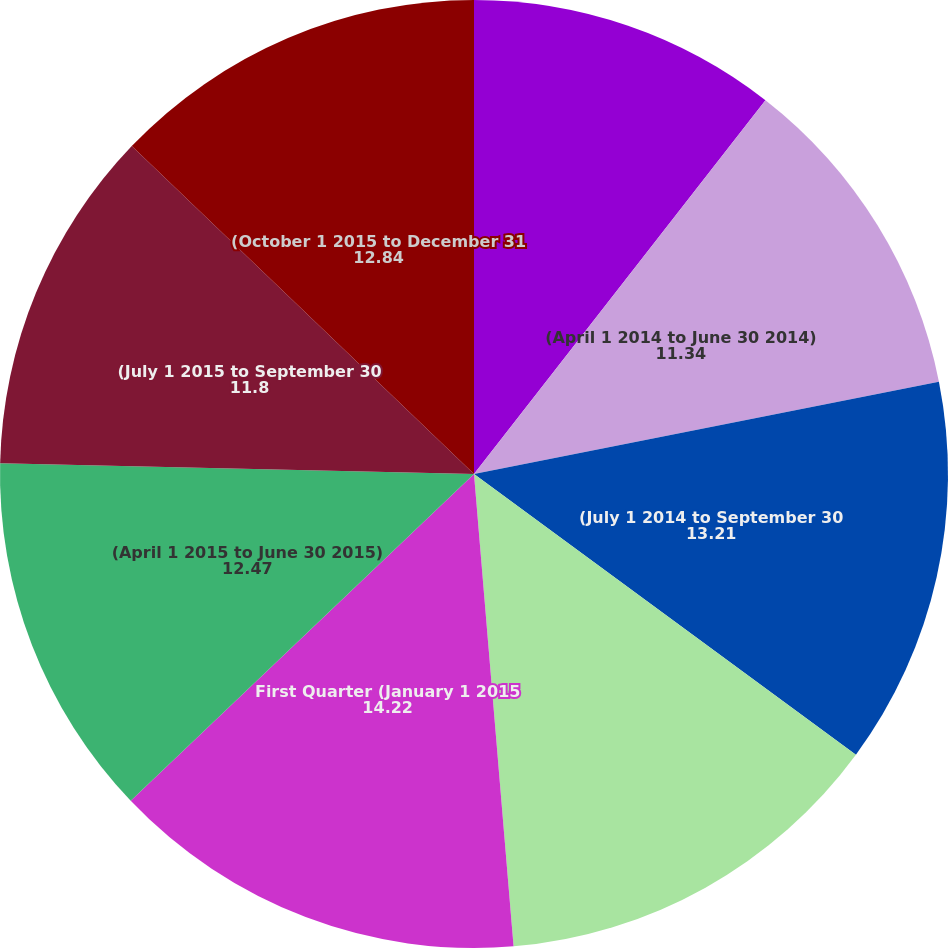Convert chart to OTSL. <chart><loc_0><loc_0><loc_500><loc_500><pie_chart><fcel>(January 1 2014 to March 31<fcel>(April 1 2014 to June 30 2014)<fcel>(July 1 2014 to September 30<fcel>(October 1 2014 to December 31<fcel>First Quarter (January 1 2015<fcel>(April 1 2015 to June 30 2015)<fcel>(July 1 2015 to September 30<fcel>(October 1 2015 to December 31<nl><fcel>10.54%<fcel>11.34%<fcel>13.21%<fcel>13.58%<fcel>14.22%<fcel>12.47%<fcel>11.8%<fcel>12.84%<nl></chart> 